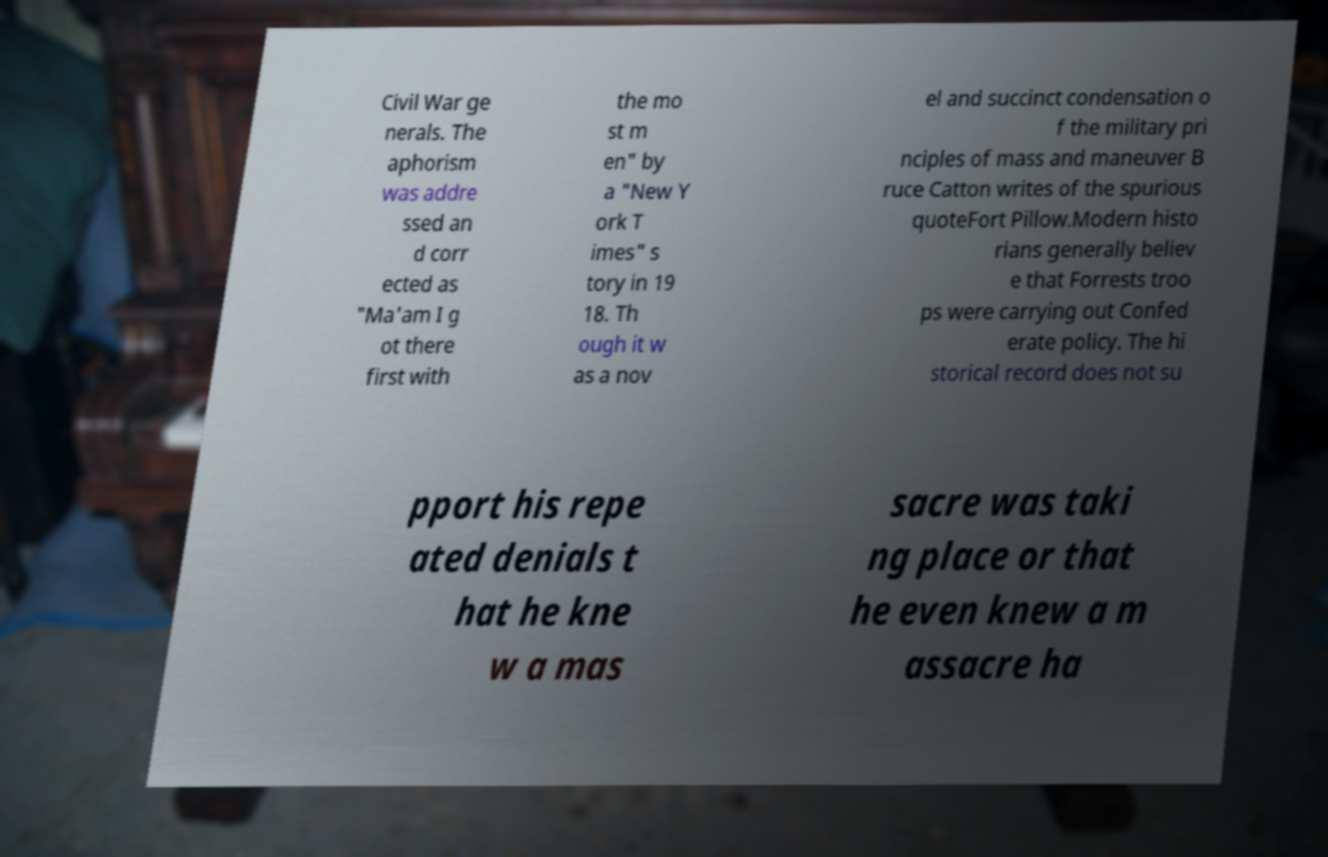Who is Bruce Catton mentioned in the text, and why might his perspective be important? Bruce Catton was an American historian and journalist, known for his books on the American Civil War. He won a Pulitzer Prize for history and is regarded for his accessible style and depth of analysis. His perspective is important because it provides a well-researched and detailed account of Civil War events, helping to shape public understanding of this complex period in American history. 